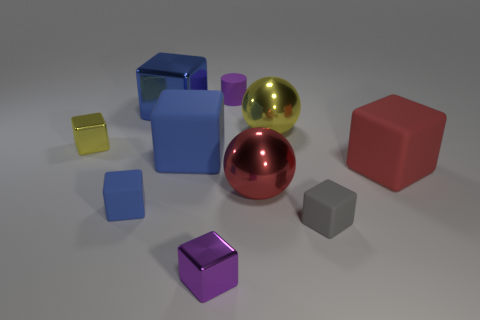How many blue blocks must be subtracted to get 1 blue blocks? 2 Subtract all red cubes. How many cubes are left? 6 Subtract all red balls. How many balls are left? 1 Subtract all cylinders. How many objects are left? 9 Subtract 1 cylinders. How many cylinders are left? 0 Subtract all red spheres. Subtract all brown cubes. How many spheres are left? 1 Subtract all cyan balls. How many purple blocks are left? 1 Subtract all blue rubber objects. Subtract all small gray rubber things. How many objects are left? 7 Add 6 big red metal objects. How many big red metal objects are left? 7 Add 1 tiny purple cubes. How many tiny purple cubes exist? 2 